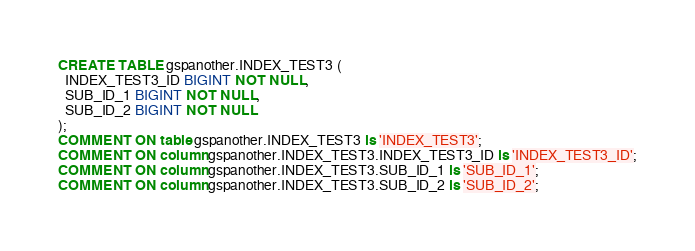Convert code to text. <code><loc_0><loc_0><loc_500><loc_500><_SQL_>CREATE TABLE gspanother.INDEX_TEST3 (
  INDEX_TEST3_ID BIGINT NOT NULL,
  SUB_ID_1 BIGINT NOT NULL,
  SUB_ID_2 BIGINT NOT NULL
);
COMMENT ON table gspanother.INDEX_TEST3 is 'INDEX_TEST3';
COMMENT ON column gspanother.INDEX_TEST3.INDEX_TEST3_ID is 'INDEX_TEST3_ID';
COMMENT ON column gspanother.INDEX_TEST3.SUB_ID_1 is 'SUB_ID_1';
COMMENT ON column gspanother.INDEX_TEST3.SUB_ID_2 is 'SUB_ID_2';
</code> 